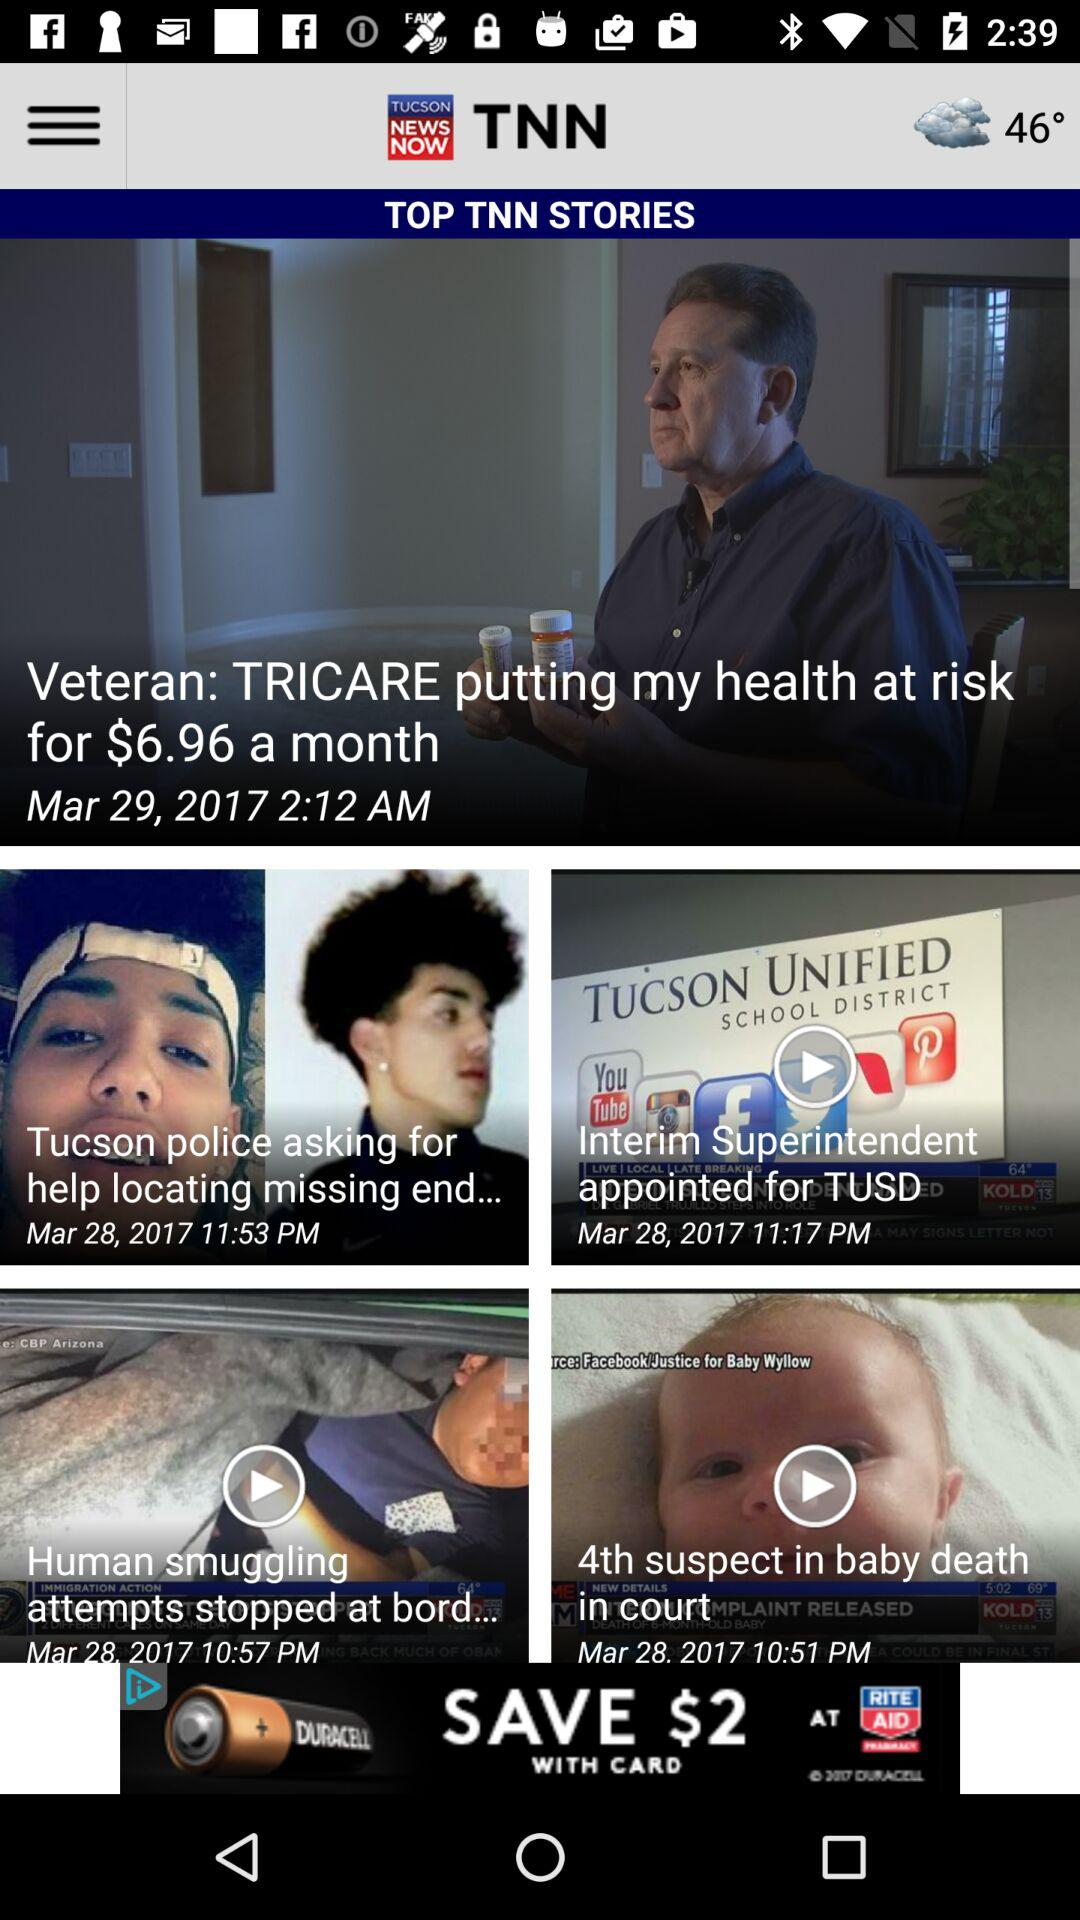On what date was the news "4th suspect in baby death in court" posted? The news was posted on March 28, 2017. 